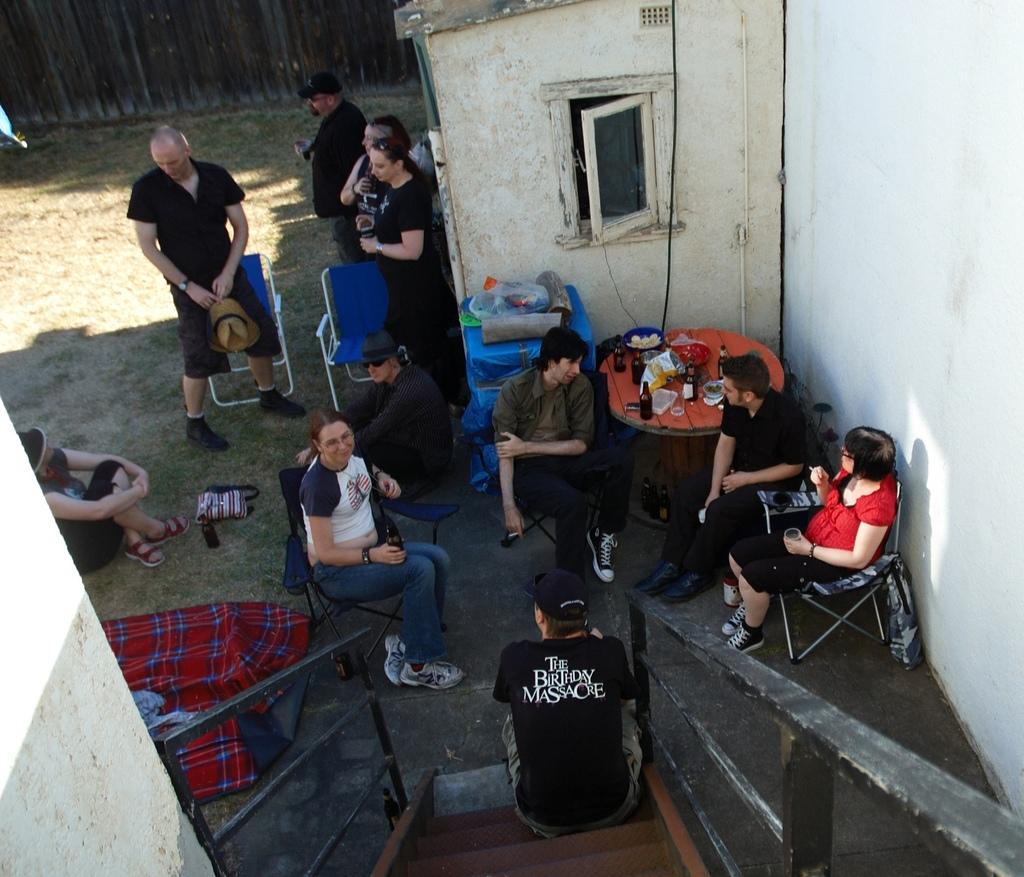What are the people in the image doing? There are people sitting on chairs and some people are standing in the image. What can be seen on the table in the image? There is a table in the image with bottles, glasses, and eatable items on it. How many types of items are on the table? There are at least three types of items on the table: bottles, glasses, and eatable items. What type of arithmetic problem can be solved using the machine on the table in the image? There is no machine present on the table in the image, so it is not possible to solve any arithmetic problems using it. What type of quill is being used by the person in the image? There is no quill present in the image, so it is not possible to determine what type of quill might be used. 